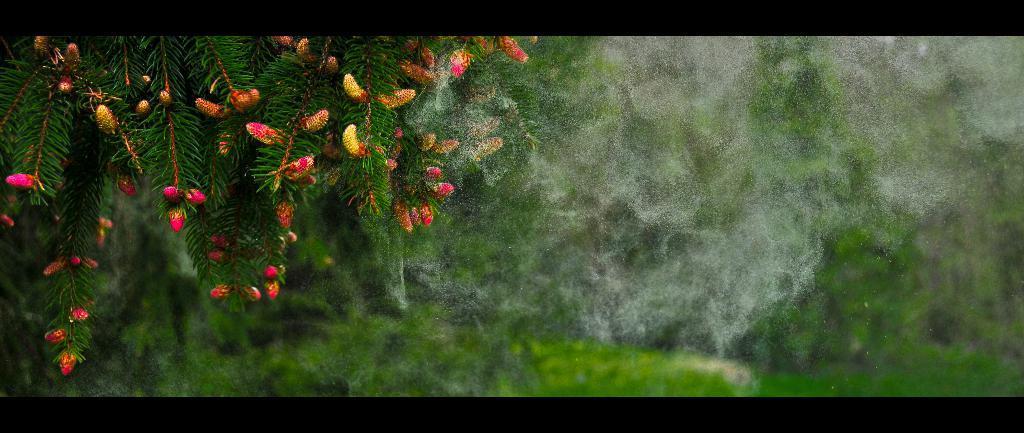Please provide a concise description of this image. In this image I can see a tree. The background is blurred. 